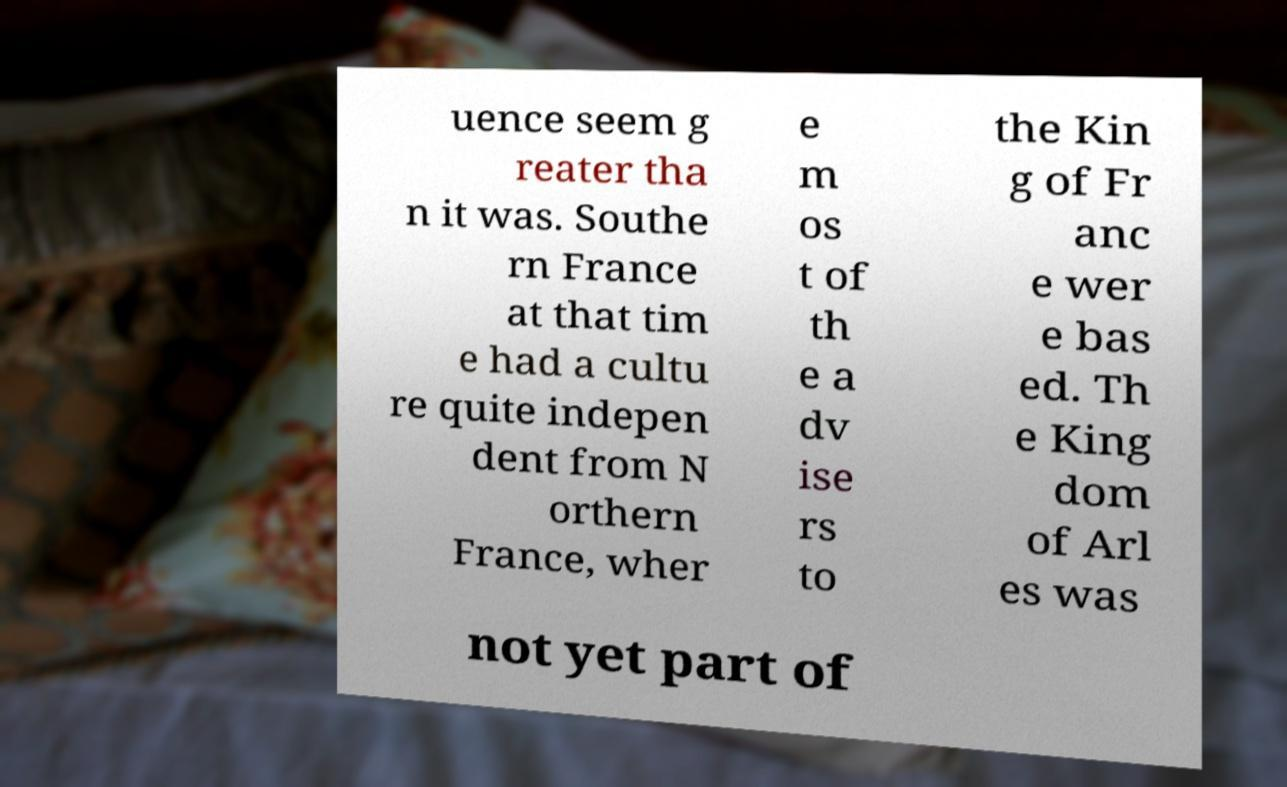Please read and relay the text visible in this image. What does it say? uence seem g reater tha n it was. Southe rn France at that tim e had a cultu re quite indepen dent from N orthern France, wher e m os t of th e a dv ise rs to the Kin g of Fr anc e wer e bas ed. Th e King dom of Arl es was not yet part of 